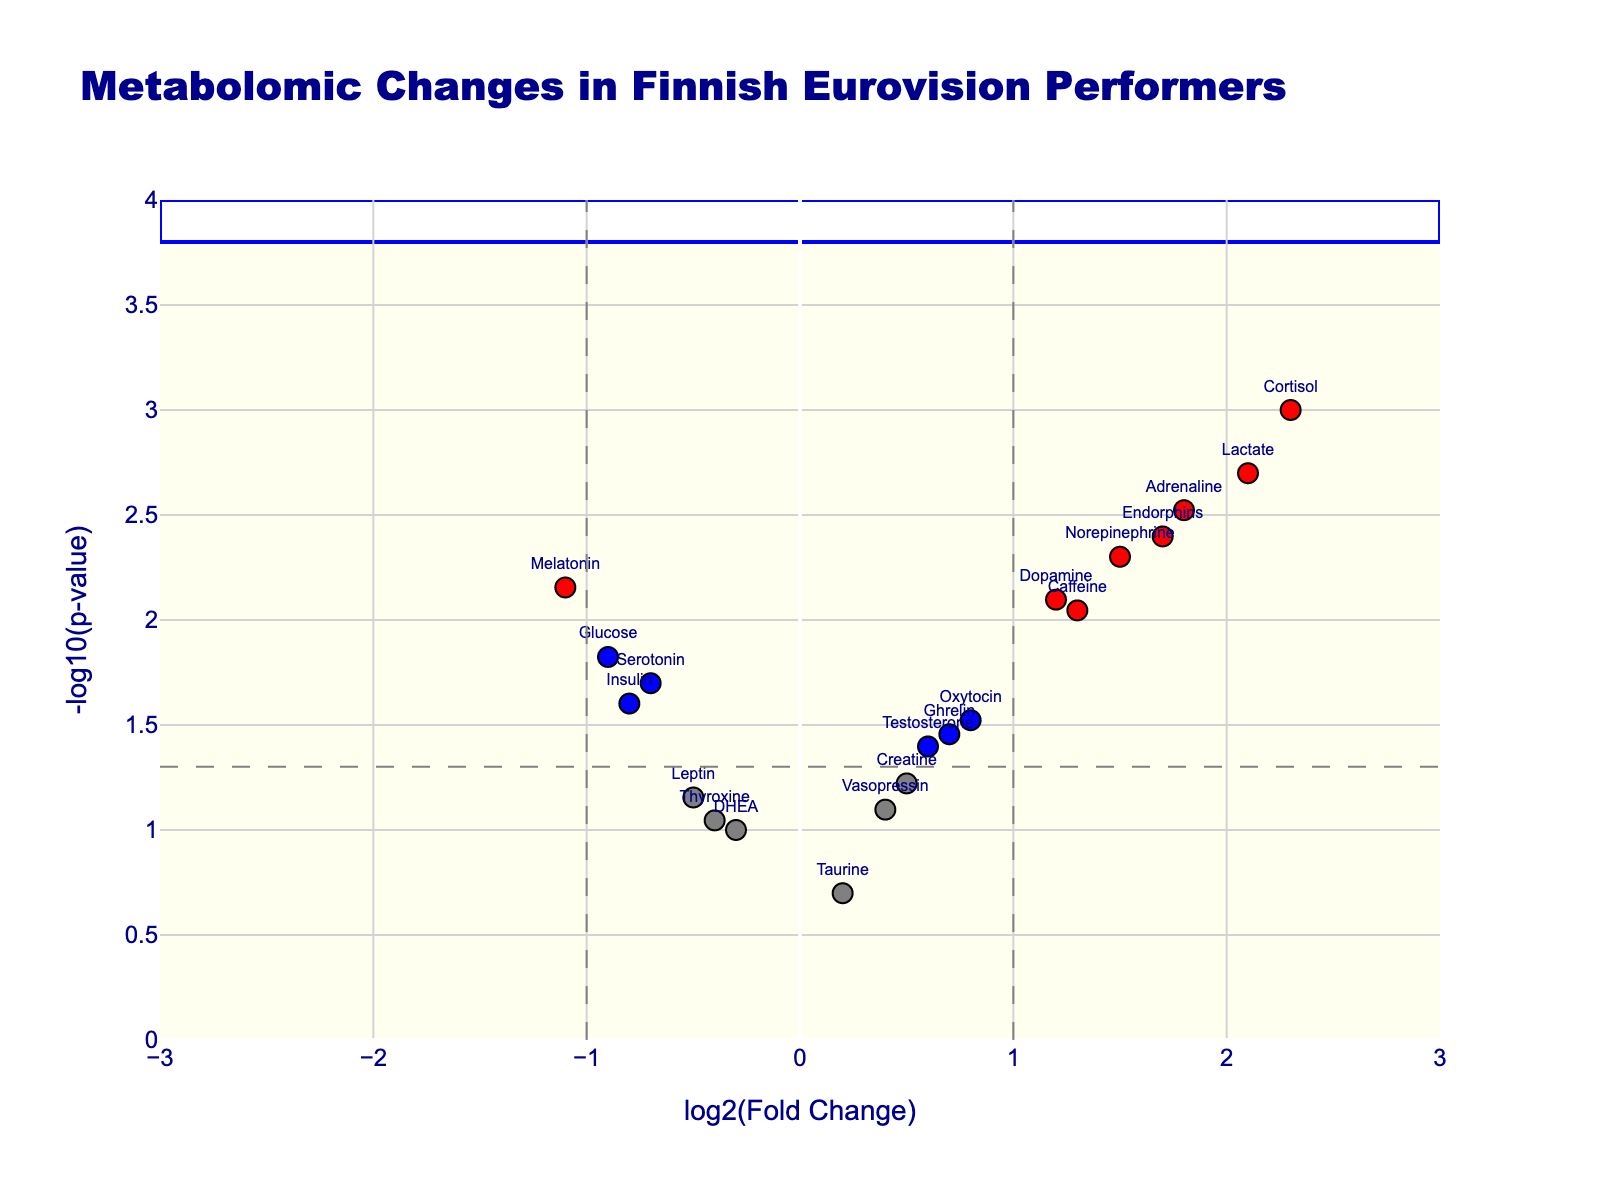What's the title of the plot? The title is displayed at the top of the plot and gives an overview of what the plot represents. It reads "Metabolomic Changes in Finnish Eurovision Performers."
Answer: Metabolomic Changes in Finnish Eurovision Performers How many metabolites have significant changes with a p-value less than 0.05? To determine the number of significantly changed metabolites, we count the markers that are either red or blue, as these colors indicate significance with a p-value < 0.05.
Answer: 13 Which metabolite shows the highest log2(fold change)? By observing the x-axis labeled "log2(Fold Change)," we look for the data point farthest to the right. Cortisol, with the highest value on the x-axis, stands out.
Answer: Cortisol Which metabolite exhibits the lowest p-value? The y-axis labeled "-log10(p-value)" implies that higher values represent lower p-values. The metabolite with the highest y-axis value corresponds to having the lowest p-value, which is Cortisol.
Answer: Cortisol What color indicates metabolites that are significantly different with both high fold change and low p-value? The legend or color scheme indicates that red markers show metabolites meeting these criteria.
Answer: Red How many metabolites are shown as gray markers, and what does this indicate? Gray markers represent metabolites that neither have significant fold changes nor p-values. By counting the gray markers in the plot, we find that there are three.
Answer: 3 Are there more metabolites with downregulated log2(fold change) or upregulated log2(fold change)? By comparing counts of blue and gray markers on the left (negative log2FC) to those on the right (positive log2FC), it becomes evident which side has more markers. Notably, there are more upregulated (right/positive) reflecting the markers on the right.
Answer: Upregulated Which metabolite is closest to the origin, indicating minimal change in both fold change and p-value? The marker nearest to the axis origin (0,0) on both x and y indicates minimal change. Taurine is closest to this point.
Answer: Taurine What is the significance threshold in terms of p-value as shown on the plot? The horizontal dashed line indicates the threshold for p-value significance. By converting the dash line value on the y-axis, which is -log10(0.05), the threshold p-value is 0.05.
Answer: 0.05 